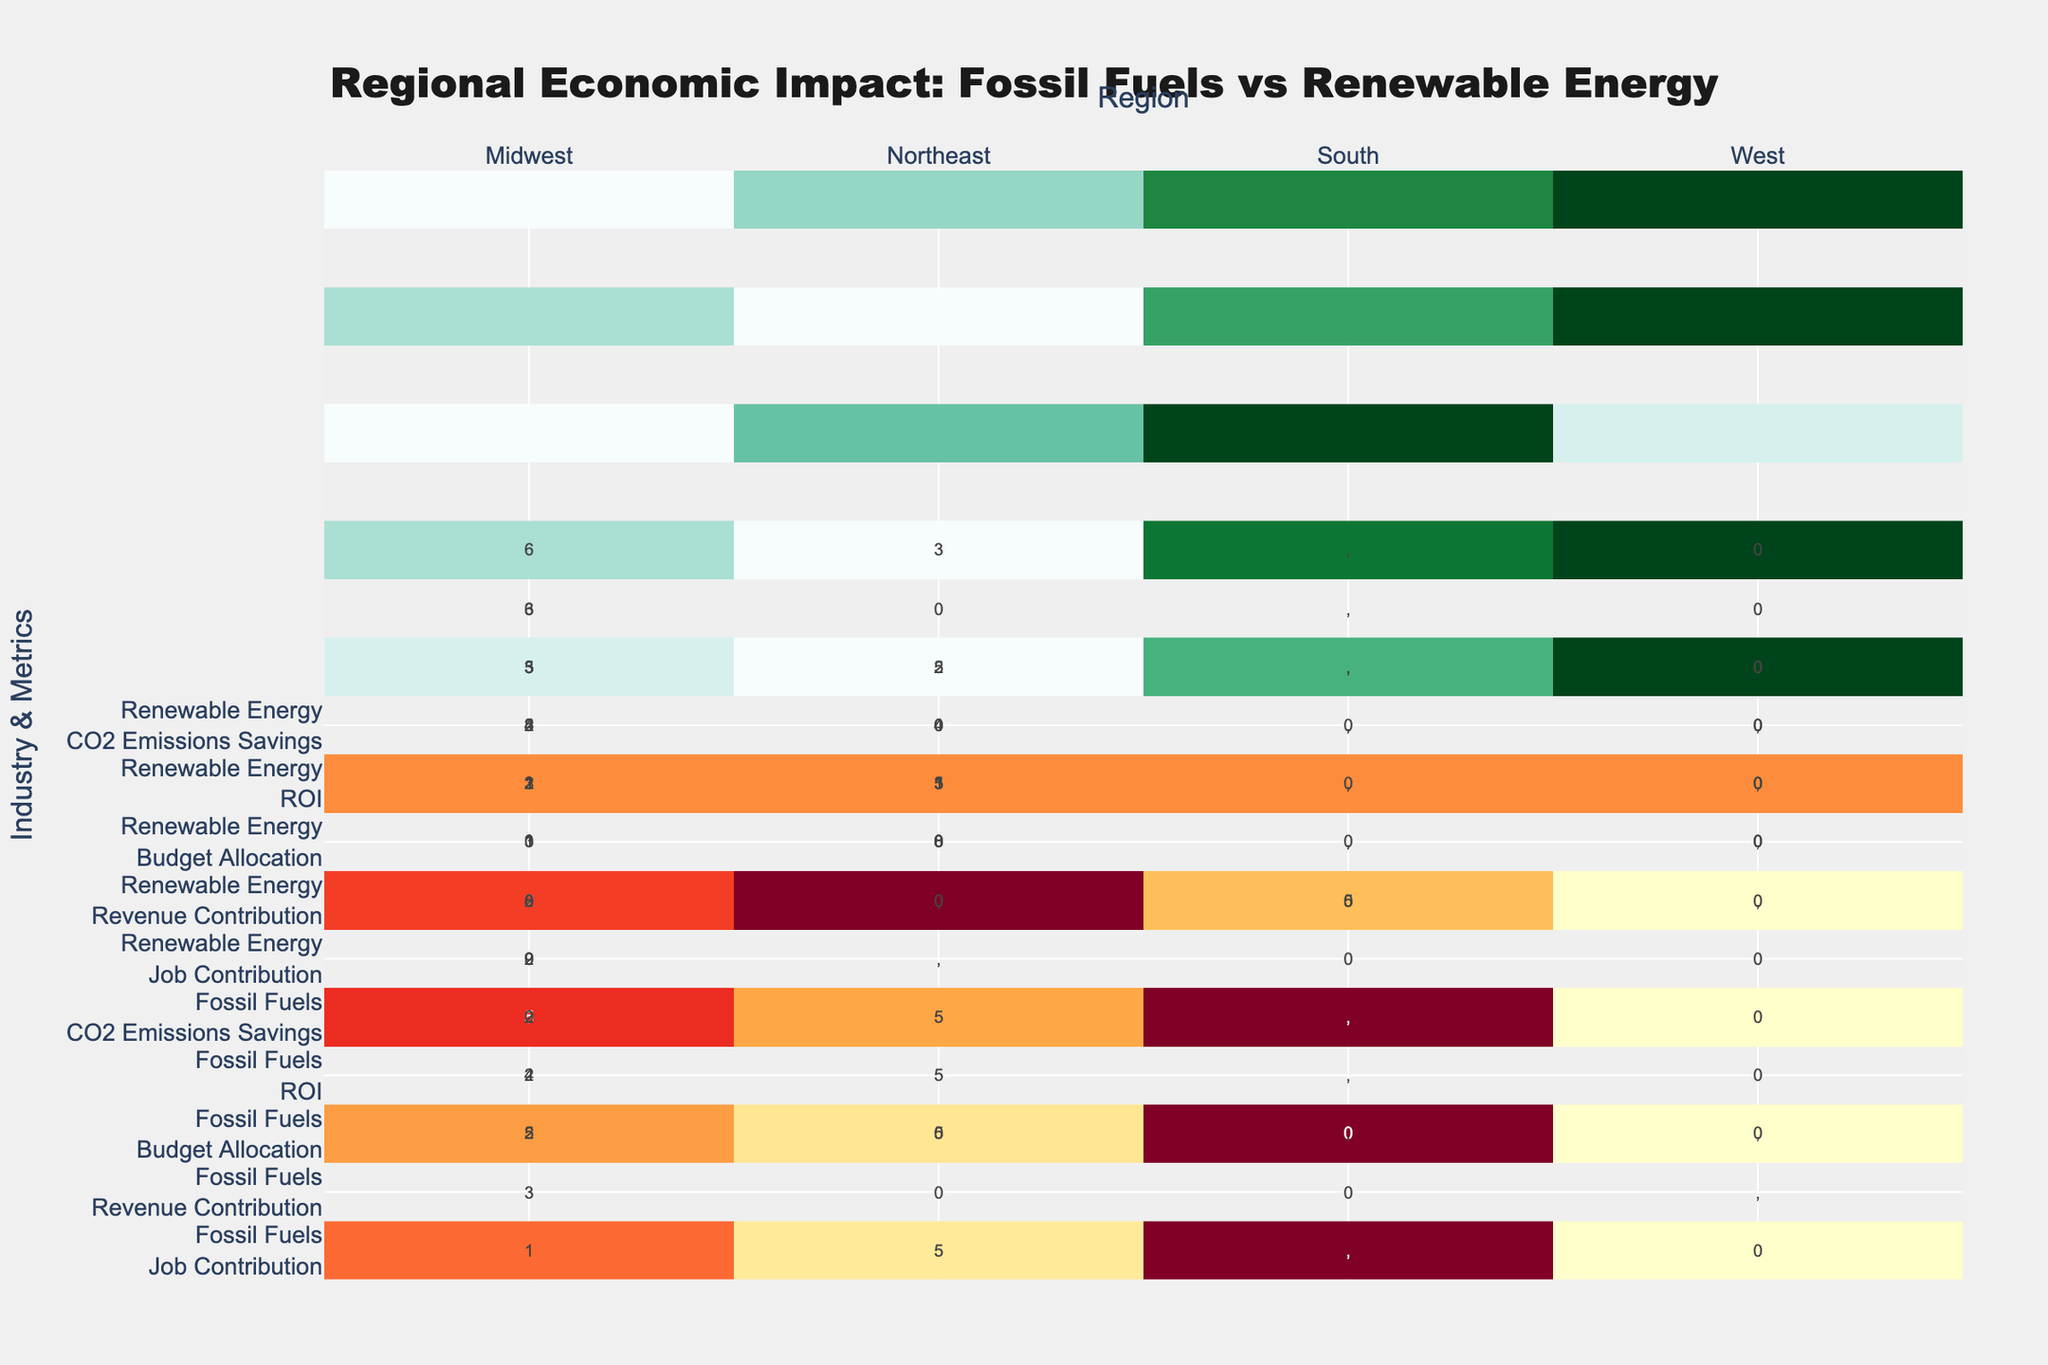What's the title of the figure? The title of the figure is located at the top center. It reads "Regional Economic Impact: Fossil Fuels vs Renewable Energy".
Answer: Regional Economic Impact: Fossil Fuels vs Renewable Energy What are the regions compared in this heatmap? Look at the x-axis labels to see the regions compared in the heatmap. They are the Midwest, Northeast, South, and West.
Answer: Midwest, Northeast, South, West How do the colors differ for fossil fuels and renewable energy in the heatmap? Fossil fuels are represented by a colorscale ranging from yellow to red (YlOrRd), while renewable energy is represented by a colorscale ranging from blue to green (BuGn).
Answer: Yellow to red for fossil fuels, blue to green for renewable energy Which region has the highest job contribution from fossil fuels? Examine the color intensity for "Job Contribution" under the fossil fuels row. The South region has the darkest color, indicating the highest job contribution.
Answer: South What’s the average revenue contribution of renewable energy across all regions? Calculate the average by summing the revenue contributions for all regions under renewable energy and dividing by the number of regions: (200,000,000 + 180,000,000 + 230,000,000 + 240,000,000) / 4 = 850,000,000 / 4 = 212,500,000
Answer: 212,500,000 Which region has the lowest ROI for renewable energy? Compare the text values for "ROI" under the renewable energy row for all regions. The Northeast has the lowest ROI of 2.4.
Answer: Northeast Considering CO2 emissions savings, how much more does the west save compared to the midwest? Subtract the CO2 emissions savings for the Midwest from the West: 63,000,000 - 50,000,000 = 13,000,000.
Answer: 13,000,000 Which industry has a higher budget allocation in the Northeast? Compare the text values under "Budget Allocation" for both industries in the Northeast. Fossil Fuels have a higher budget allocation of 45,000,000, compared to 35,000,000 for Renewable Energy.
Answer: Fossil Fuels What’s the total job contribution from both industries in the West? Sum the job contributions for both industry types in the West: 11,000 (Fossil Fuels) + 11,000 (Renewable Energy) = 22,000.
Answer: 22,000 Which region shows the highest CO2 emissions savings from renewable energy? Compare the text values under "CO2 Emissions Savings" for the renewable energy row. The West has the highest savings with 63,000,000.
Answer: West 